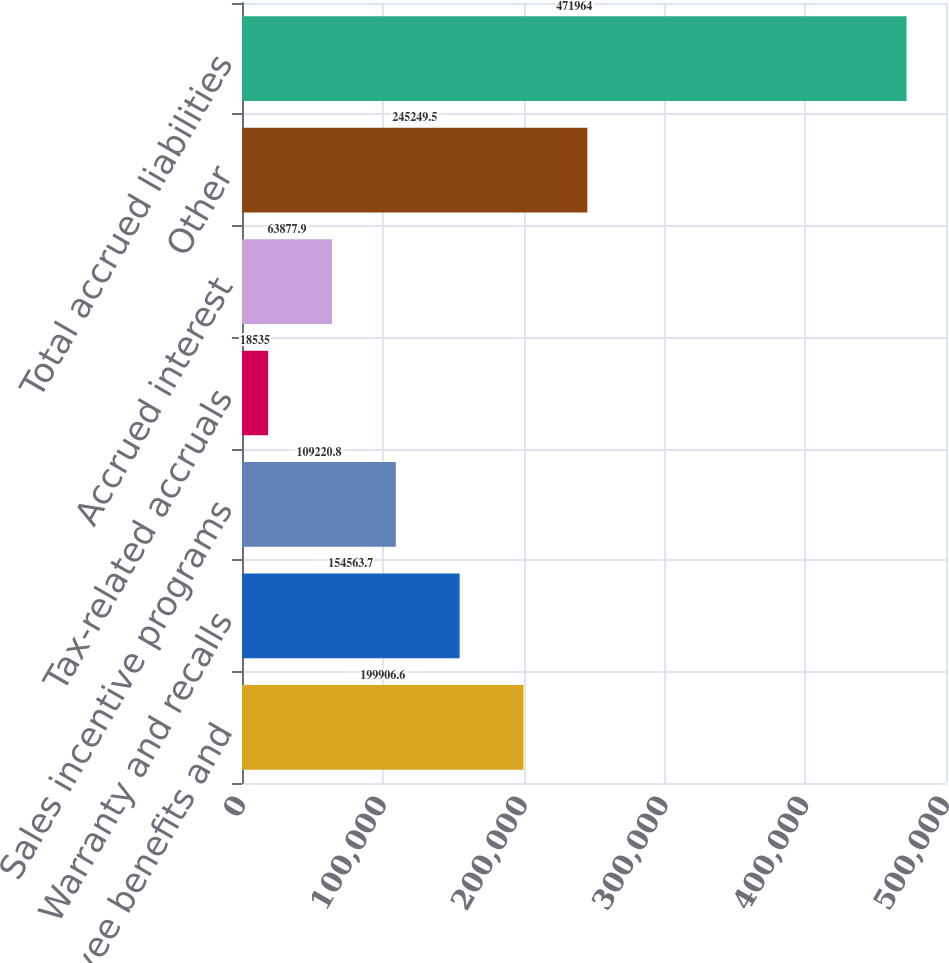Convert chart to OTSL. <chart><loc_0><loc_0><loc_500><loc_500><bar_chart><fcel>Payroll employee benefits and<fcel>Warranty and recalls<fcel>Sales incentive programs<fcel>Tax-related accruals<fcel>Accrued interest<fcel>Other<fcel>Total accrued liabilities<nl><fcel>199907<fcel>154564<fcel>109221<fcel>18535<fcel>63877.9<fcel>245250<fcel>471964<nl></chart> 